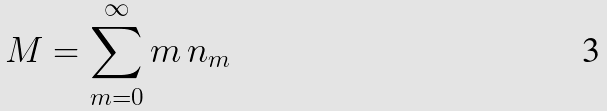Convert formula to latex. <formula><loc_0><loc_0><loc_500><loc_500>M = \sum _ { m = 0 } ^ { \infty } m \, n _ { m }</formula> 